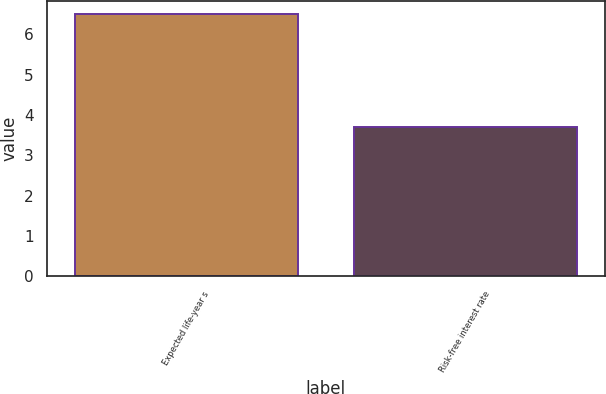<chart> <loc_0><loc_0><loc_500><loc_500><bar_chart><fcel>Expected life-year s<fcel>Risk-free interest rate<nl><fcel>6.5<fcel>3.71<nl></chart> 